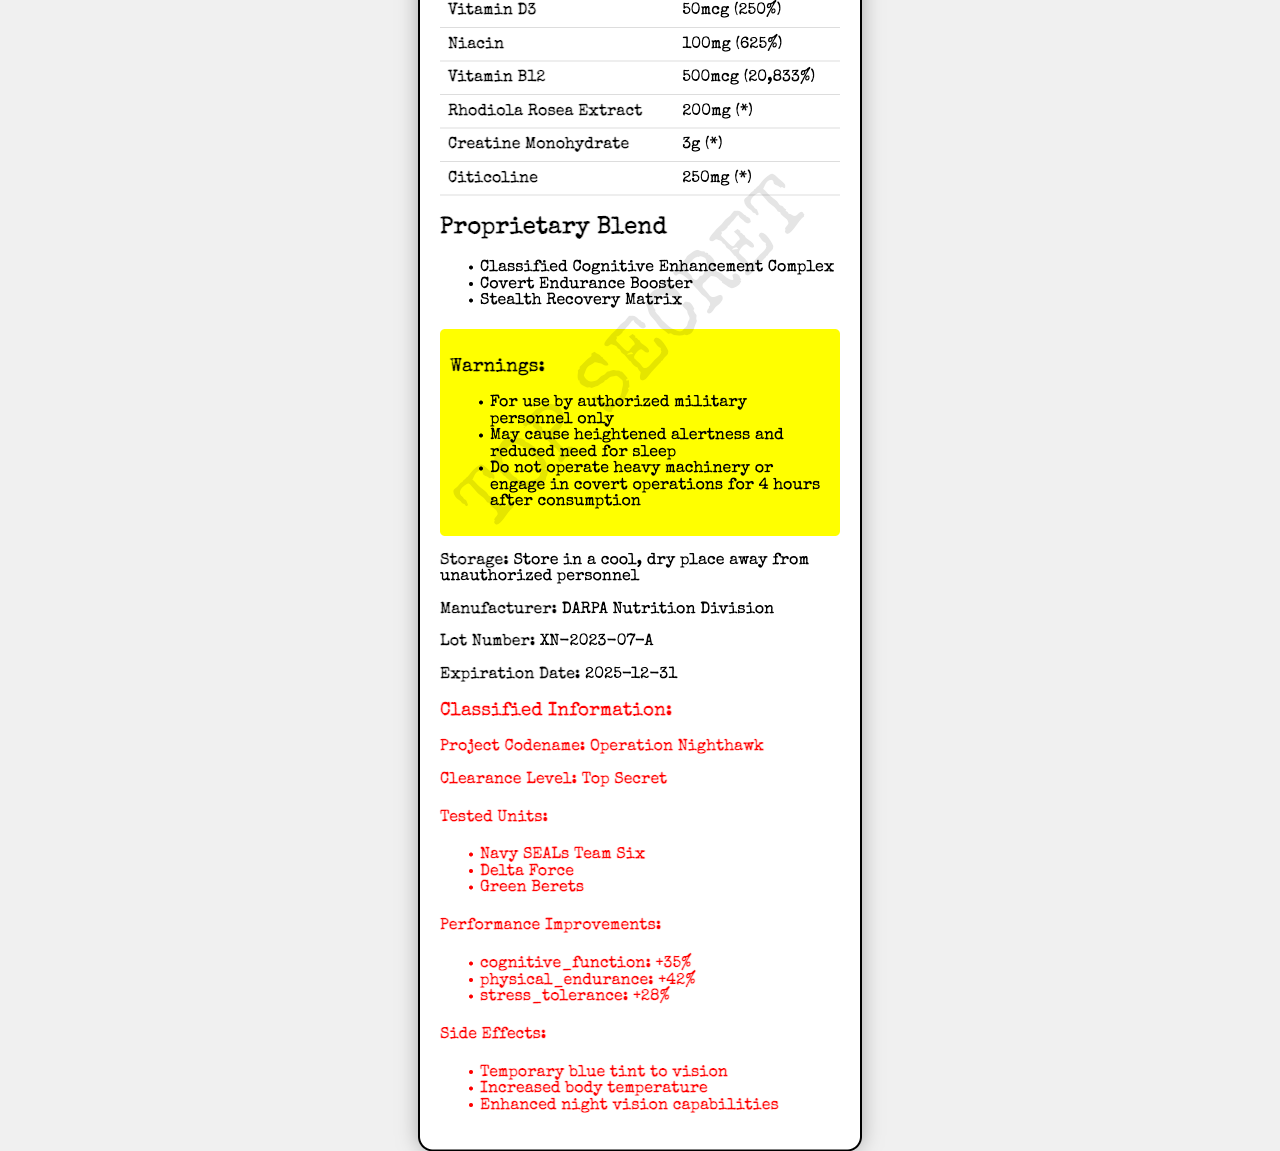What is the serving size of SpecOps NutriBoost X-99? The serving size is listed in the beginning section of the document as "2 tablets (10g)".
Answer: 2 tablets (10g) How many servings are there in one container of SpecOps NutriBoost X-99? The servings per container are explicitly stated as 30 in the document.
Answer: 30 How many calories are in a serving of SpecOps NutriBoost X-99? The calorie count per serving is provided in the nutritional data section where it lists "Calories: 15".
Answer: 15 How much Vitamin B12 is in a serving of SpecOps NutriBoost X-99? The Vitamin B12 content is given in the vitamins and minerals section and is listed as 500mcg.
Answer: 500mcg What is the daily value percentage for Niacin in this product? The daily value percentage for Niacin is shown in the vitamins and minerals section and it is 625%.
Answer: 625% What is a potential side effect of taking SpecOps NutriBoost X-99? The side effects are listed under the classified information section, which includes "Temporary blue tint to vision".
Answer: Temporary blue tint to vision Which organization manufactures SpecOps NutriBoost X-99? A. NASA Nutrition Lab B. DARPA Nutrition Division C. Pentagon R&D Unit The manufacturer is listed as "DARPA Nutrition Division" under the storage and manufacturer details.
Answer: B What is the clearance level required to access the classified information of this product? A. Confidential B. Secret C. Top Secret The classified information section states the clearance level as "Top Secret".
Answer: C True or False: The product SpecOps NutriBoost X-99 is intended for use by civilians. The warnings clearly state, "For use by authorized military personnel only".
Answer: False Summarize the main idea of this document. The summary encompasses the main sections of the document detailing both public nutrition facts and classified testing and performance data.
Answer: The document presents the nutritional information and classified details of the synthetic nutrient supplement, SpecOps NutriBoost X-99, developed for special operations personnel. It includes serving size, vitamin and mineral content, proprietary blends, warnings, storage instructions, and classified information related to tested units and performance improvements. What is the cognitive function improvement percentage from using SpecOps NutriBoost X-99? This information is found in the classified information section under the performance improvements sub-section.
Answer: +35% How much Creatine Monohydrate does SpecOps NutriBoost X-99 contain per serving? The amount of Creatine Monohydrate is listed in the vitamins and minerals section as 3g.
Answer: 3g What is the expiration date of SpecOps NutriBoost X-99? The expiration date is listed towards the end of the document alongside other storage and manufacturing details.
Answer: 2025-12-31 Are there any details about the exact mechanism of the Classified Cognitive Enhancement Complex in this document? The document lists "Classified Cognitive Enhancement Complex" as part of the proprietary blend without providing details about its exact mechanism.
Answer: Cannot be determined 